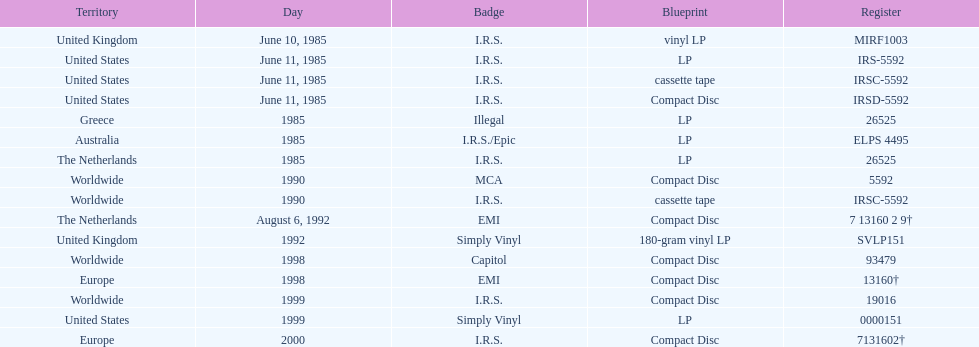What is the greatest consecutive amount of releases in lp format? 3. 